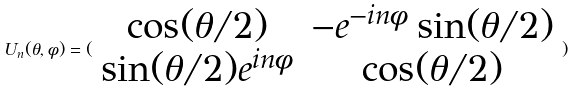Convert formula to latex. <formula><loc_0><loc_0><loc_500><loc_500>U _ { n } ( \theta , \phi ) = ( \begin{array} { c c } \cos ( \theta / 2 ) & - e ^ { - i n \phi } \sin ( \theta / 2 ) \\ \sin ( \theta / 2 ) e ^ { i n \phi } & \cos ( \theta / 2 ) \end{array} )</formula> 